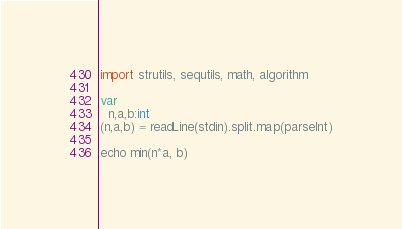<code> <loc_0><loc_0><loc_500><loc_500><_Nim_>import strutils, sequtils, math, algorithm

var
  n,a,b:int
(n,a,b) = readLine(stdin).split.map(parseInt)

echo min(n*a, b)
</code> 